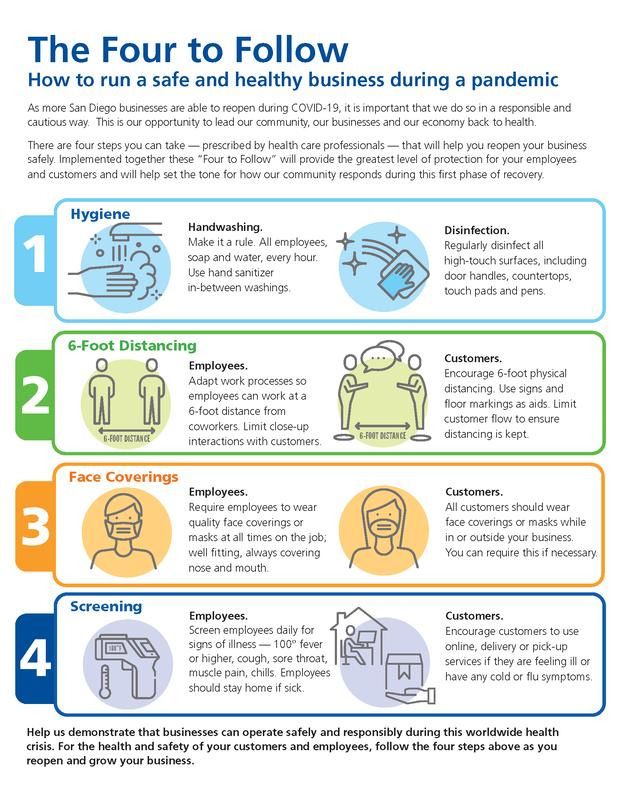Specify some key components in this picture. The quality of a mask mentioned in the infographic is its well-fitting nature. The different types of aids include signs, floor markings, and other visual cues that are used to support communication and facilitate the understanding of information for individuals with autism or other communication challenges. 